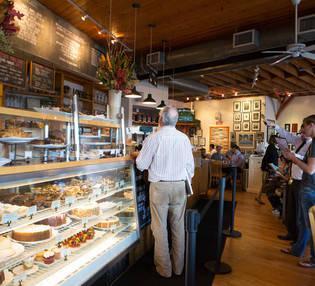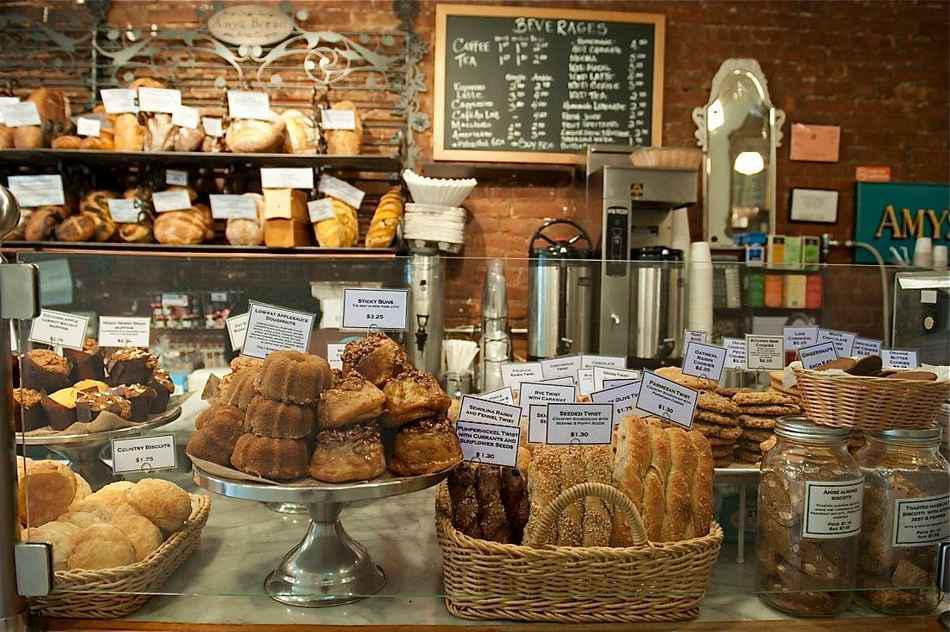The first image is the image on the left, the second image is the image on the right. Analyze the images presented: Is the assertion "At least one woman with her hair up is working behind the counter of one bakery." valid? Answer yes or no. No. The first image is the image on the left, the second image is the image on the right. Evaluate the accuracy of this statement regarding the images: "The only humans visible appear to be workers.". Is it true? Answer yes or no. No. 